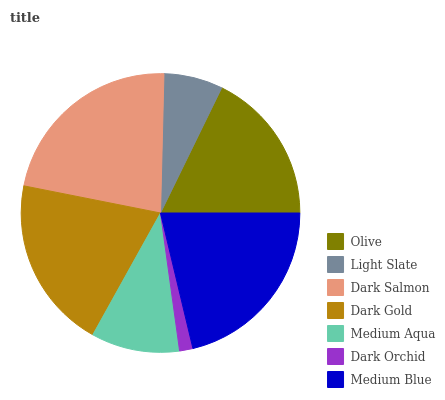Is Dark Orchid the minimum?
Answer yes or no. Yes. Is Dark Salmon the maximum?
Answer yes or no. Yes. Is Light Slate the minimum?
Answer yes or no. No. Is Light Slate the maximum?
Answer yes or no. No. Is Olive greater than Light Slate?
Answer yes or no. Yes. Is Light Slate less than Olive?
Answer yes or no. Yes. Is Light Slate greater than Olive?
Answer yes or no. No. Is Olive less than Light Slate?
Answer yes or no. No. Is Olive the high median?
Answer yes or no. Yes. Is Olive the low median?
Answer yes or no. Yes. Is Dark Gold the high median?
Answer yes or no. No. Is Light Slate the low median?
Answer yes or no. No. 